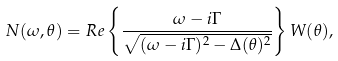<formula> <loc_0><loc_0><loc_500><loc_500>N ( \omega , \theta ) = R e \left \{ \frac { \omega - i \Gamma } { \sqrt { ( \omega - i \Gamma ) ^ { 2 } - \Delta ( \theta ) ^ { 2 } } } \right \} W ( \theta ) ,</formula> 